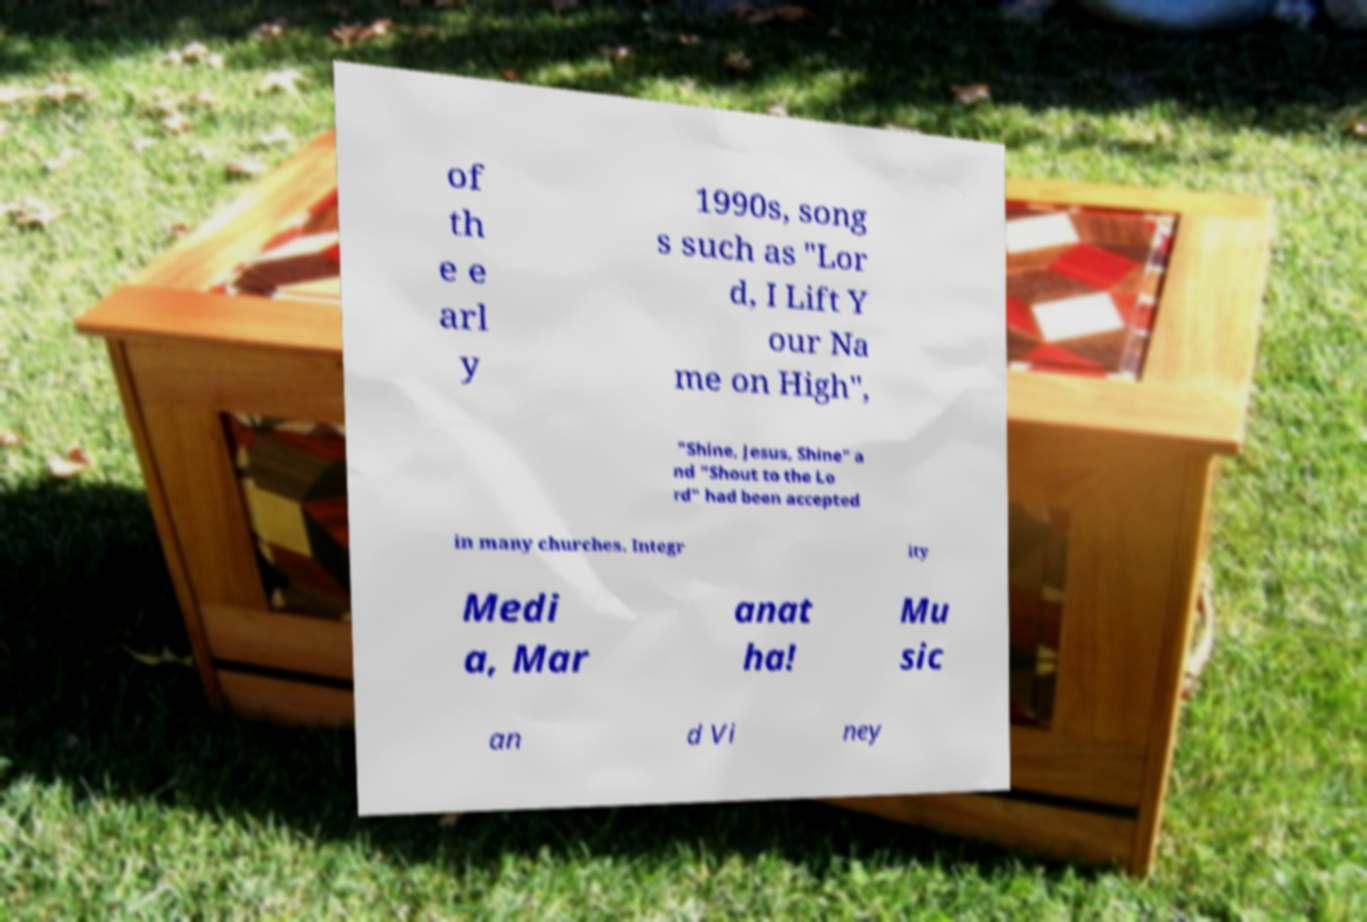What messages or text are displayed in this image? I need them in a readable, typed format. of th e e arl y 1990s, song s such as "Lor d, I Lift Y our Na me on High", "Shine, Jesus, Shine" a nd "Shout to the Lo rd" had been accepted in many churches. Integr ity Medi a, Mar anat ha! Mu sic an d Vi ney 